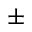<formula> <loc_0><loc_0><loc_500><loc_500>\pm</formula> 